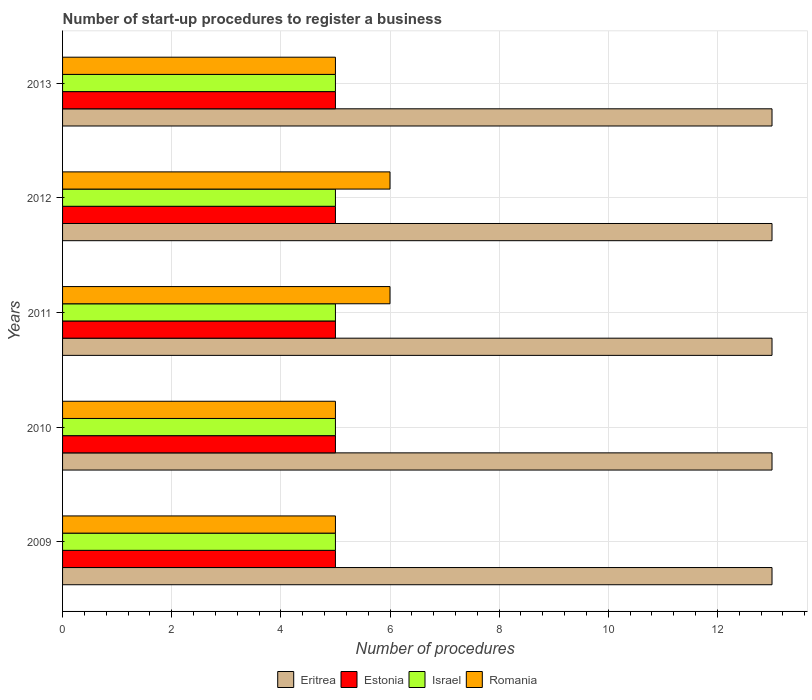How many different coloured bars are there?
Make the answer very short. 4. How many groups of bars are there?
Your answer should be compact. 5. Are the number of bars per tick equal to the number of legend labels?
Your answer should be very brief. Yes. Are the number of bars on each tick of the Y-axis equal?
Keep it short and to the point. Yes. How many bars are there on the 4th tick from the top?
Provide a succinct answer. 4. What is the label of the 3rd group of bars from the top?
Offer a terse response. 2011. In how many cases, is the number of bars for a given year not equal to the number of legend labels?
Give a very brief answer. 0. What is the number of procedures required to register a business in Israel in 2011?
Give a very brief answer. 5. Across all years, what is the maximum number of procedures required to register a business in Israel?
Ensure brevity in your answer.  5. In which year was the number of procedures required to register a business in Romania maximum?
Your response must be concise. 2011. What is the total number of procedures required to register a business in Israel in the graph?
Provide a succinct answer. 25. What is the difference between the number of procedures required to register a business in Israel in 2010 and that in 2012?
Offer a terse response. 0. In the year 2009, what is the difference between the number of procedures required to register a business in Israel and number of procedures required to register a business in Romania?
Your response must be concise. 0. What is the ratio of the number of procedures required to register a business in Estonia in 2012 to that in 2013?
Provide a succinct answer. 1. Is the number of procedures required to register a business in Eritrea in 2012 less than that in 2013?
Provide a succinct answer. No. Is the difference between the number of procedures required to register a business in Israel in 2012 and 2013 greater than the difference between the number of procedures required to register a business in Romania in 2012 and 2013?
Your answer should be compact. No. What is the difference between the highest and the lowest number of procedures required to register a business in Eritrea?
Give a very brief answer. 0. In how many years, is the number of procedures required to register a business in Estonia greater than the average number of procedures required to register a business in Estonia taken over all years?
Offer a terse response. 0. Is it the case that in every year, the sum of the number of procedures required to register a business in Eritrea and number of procedures required to register a business in Israel is greater than the sum of number of procedures required to register a business in Romania and number of procedures required to register a business in Estonia?
Your answer should be very brief. Yes. What does the 2nd bar from the top in 2012 represents?
Provide a succinct answer. Israel. What does the 1st bar from the bottom in 2010 represents?
Make the answer very short. Eritrea. Is it the case that in every year, the sum of the number of procedures required to register a business in Israel and number of procedures required to register a business in Estonia is greater than the number of procedures required to register a business in Romania?
Make the answer very short. Yes. How many bars are there?
Provide a succinct answer. 20. Are all the bars in the graph horizontal?
Offer a terse response. Yes. How many years are there in the graph?
Your response must be concise. 5. Does the graph contain any zero values?
Give a very brief answer. No. Does the graph contain grids?
Give a very brief answer. Yes. Where does the legend appear in the graph?
Offer a terse response. Bottom center. How are the legend labels stacked?
Ensure brevity in your answer.  Horizontal. What is the title of the graph?
Give a very brief answer. Number of start-up procedures to register a business. Does "Andorra" appear as one of the legend labels in the graph?
Make the answer very short. No. What is the label or title of the X-axis?
Provide a succinct answer. Number of procedures. What is the label or title of the Y-axis?
Your response must be concise. Years. What is the Number of procedures in Eritrea in 2009?
Provide a succinct answer. 13. What is the Number of procedures in Estonia in 2009?
Give a very brief answer. 5. What is the Number of procedures of Israel in 2009?
Give a very brief answer. 5. What is the Number of procedures in Romania in 2009?
Provide a succinct answer. 5. What is the Number of procedures of Eritrea in 2010?
Your response must be concise. 13. What is the Number of procedures in Estonia in 2010?
Your response must be concise. 5. What is the Number of procedures in Israel in 2010?
Keep it short and to the point. 5. What is the Number of procedures of Romania in 2010?
Keep it short and to the point. 5. What is the Number of procedures in Israel in 2011?
Provide a succinct answer. 5. What is the Number of procedures in Romania in 2011?
Make the answer very short. 6. What is the Number of procedures of Eritrea in 2012?
Your answer should be compact. 13. What is the Number of procedures in Estonia in 2012?
Your answer should be compact. 5. Across all years, what is the maximum Number of procedures in Eritrea?
Keep it short and to the point. 13. Across all years, what is the maximum Number of procedures of Romania?
Keep it short and to the point. 6. Across all years, what is the minimum Number of procedures of Eritrea?
Your answer should be very brief. 13. Across all years, what is the minimum Number of procedures of Israel?
Your answer should be compact. 5. Across all years, what is the minimum Number of procedures in Romania?
Your answer should be very brief. 5. What is the total Number of procedures in Eritrea in the graph?
Make the answer very short. 65. What is the total Number of procedures in Estonia in the graph?
Provide a succinct answer. 25. What is the difference between the Number of procedures in Estonia in 2009 and that in 2010?
Provide a succinct answer. 0. What is the difference between the Number of procedures of Romania in 2009 and that in 2010?
Your response must be concise. 0. What is the difference between the Number of procedures in Eritrea in 2009 and that in 2011?
Ensure brevity in your answer.  0. What is the difference between the Number of procedures of Romania in 2009 and that in 2012?
Give a very brief answer. -1. What is the difference between the Number of procedures of Eritrea in 2009 and that in 2013?
Provide a short and direct response. 0. What is the difference between the Number of procedures of Estonia in 2009 and that in 2013?
Provide a succinct answer. 0. What is the difference between the Number of procedures of Romania in 2009 and that in 2013?
Your answer should be compact. 0. What is the difference between the Number of procedures in Eritrea in 2010 and that in 2011?
Your response must be concise. 0. What is the difference between the Number of procedures of Estonia in 2010 and that in 2012?
Ensure brevity in your answer.  0. What is the difference between the Number of procedures in Israel in 2010 and that in 2012?
Provide a succinct answer. 0. What is the difference between the Number of procedures of Romania in 2010 and that in 2012?
Your answer should be very brief. -1. What is the difference between the Number of procedures of Estonia in 2010 and that in 2013?
Keep it short and to the point. 0. What is the difference between the Number of procedures of Israel in 2010 and that in 2013?
Provide a short and direct response. 0. What is the difference between the Number of procedures of Romania in 2010 and that in 2013?
Ensure brevity in your answer.  0. What is the difference between the Number of procedures of Eritrea in 2011 and that in 2012?
Offer a terse response. 0. What is the difference between the Number of procedures in Eritrea in 2011 and that in 2013?
Give a very brief answer. 0. What is the difference between the Number of procedures in Estonia in 2011 and that in 2013?
Ensure brevity in your answer.  0. What is the difference between the Number of procedures in Israel in 2011 and that in 2013?
Ensure brevity in your answer.  0. What is the difference between the Number of procedures of Estonia in 2012 and that in 2013?
Your answer should be compact. 0. What is the difference between the Number of procedures of Israel in 2012 and that in 2013?
Ensure brevity in your answer.  0. What is the difference between the Number of procedures of Romania in 2012 and that in 2013?
Your answer should be compact. 1. What is the difference between the Number of procedures of Eritrea in 2009 and the Number of procedures of Estonia in 2010?
Provide a short and direct response. 8. What is the difference between the Number of procedures of Eritrea in 2009 and the Number of procedures of Israel in 2010?
Your answer should be very brief. 8. What is the difference between the Number of procedures in Israel in 2009 and the Number of procedures in Romania in 2010?
Provide a succinct answer. 0. What is the difference between the Number of procedures in Estonia in 2009 and the Number of procedures in Israel in 2011?
Your answer should be very brief. 0. What is the difference between the Number of procedures of Israel in 2009 and the Number of procedures of Romania in 2011?
Your answer should be very brief. -1. What is the difference between the Number of procedures in Eritrea in 2009 and the Number of procedures in Estonia in 2012?
Make the answer very short. 8. What is the difference between the Number of procedures in Eritrea in 2009 and the Number of procedures in Israel in 2012?
Provide a succinct answer. 8. What is the difference between the Number of procedures of Eritrea in 2009 and the Number of procedures of Romania in 2012?
Provide a short and direct response. 7. What is the difference between the Number of procedures of Estonia in 2009 and the Number of procedures of Israel in 2012?
Your answer should be very brief. 0. What is the difference between the Number of procedures of Eritrea in 2009 and the Number of procedures of Israel in 2013?
Offer a very short reply. 8. What is the difference between the Number of procedures of Estonia in 2009 and the Number of procedures of Israel in 2013?
Make the answer very short. 0. What is the difference between the Number of procedures in Estonia in 2009 and the Number of procedures in Romania in 2013?
Offer a very short reply. 0. What is the difference between the Number of procedures of Israel in 2009 and the Number of procedures of Romania in 2013?
Your answer should be compact. 0. What is the difference between the Number of procedures of Eritrea in 2010 and the Number of procedures of Romania in 2011?
Ensure brevity in your answer.  7. What is the difference between the Number of procedures in Israel in 2010 and the Number of procedures in Romania in 2011?
Ensure brevity in your answer.  -1. What is the difference between the Number of procedures of Eritrea in 2010 and the Number of procedures of Israel in 2012?
Your response must be concise. 8. What is the difference between the Number of procedures of Eritrea in 2010 and the Number of procedures of Israel in 2013?
Offer a terse response. 8. What is the difference between the Number of procedures in Eritrea in 2010 and the Number of procedures in Romania in 2013?
Offer a very short reply. 8. What is the difference between the Number of procedures in Estonia in 2010 and the Number of procedures in Israel in 2013?
Give a very brief answer. 0. What is the difference between the Number of procedures in Eritrea in 2011 and the Number of procedures in Romania in 2012?
Provide a short and direct response. 7. What is the difference between the Number of procedures in Estonia in 2011 and the Number of procedures in Israel in 2012?
Make the answer very short. 0. What is the difference between the Number of procedures in Israel in 2011 and the Number of procedures in Romania in 2012?
Your response must be concise. -1. What is the difference between the Number of procedures in Eritrea in 2011 and the Number of procedures in Israel in 2013?
Your answer should be compact. 8. What is the difference between the Number of procedures in Eritrea in 2011 and the Number of procedures in Romania in 2013?
Keep it short and to the point. 8. What is the difference between the Number of procedures in Estonia in 2011 and the Number of procedures in Romania in 2013?
Your answer should be very brief. 0. What is the difference between the Number of procedures of Eritrea in 2012 and the Number of procedures of Romania in 2013?
Provide a succinct answer. 8. What is the difference between the Number of procedures in Estonia in 2012 and the Number of procedures in Israel in 2013?
Your answer should be compact. 0. What is the difference between the Number of procedures of Estonia in 2012 and the Number of procedures of Romania in 2013?
Make the answer very short. 0. What is the difference between the Number of procedures of Israel in 2012 and the Number of procedures of Romania in 2013?
Your answer should be very brief. 0. What is the average Number of procedures in Israel per year?
Ensure brevity in your answer.  5. In the year 2009, what is the difference between the Number of procedures in Eritrea and Number of procedures in Estonia?
Give a very brief answer. 8. In the year 2009, what is the difference between the Number of procedures in Israel and Number of procedures in Romania?
Make the answer very short. 0. In the year 2010, what is the difference between the Number of procedures in Eritrea and Number of procedures in Estonia?
Offer a very short reply. 8. In the year 2010, what is the difference between the Number of procedures of Estonia and Number of procedures of Israel?
Give a very brief answer. 0. In the year 2011, what is the difference between the Number of procedures in Eritrea and Number of procedures in Estonia?
Your answer should be compact. 8. In the year 2011, what is the difference between the Number of procedures in Eritrea and Number of procedures in Israel?
Keep it short and to the point. 8. In the year 2011, what is the difference between the Number of procedures in Estonia and Number of procedures in Israel?
Provide a short and direct response. 0. In the year 2011, what is the difference between the Number of procedures in Estonia and Number of procedures in Romania?
Your answer should be compact. -1. In the year 2011, what is the difference between the Number of procedures in Israel and Number of procedures in Romania?
Offer a terse response. -1. In the year 2012, what is the difference between the Number of procedures of Eritrea and Number of procedures of Estonia?
Ensure brevity in your answer.  8. In the year 2012, what is the difference between the Number of procedures of Israel and Number of procedures of Romania?
Offer a terse response. -1. In the year 2013, what is the difference between the Number of procedures in Eritrea and Number of procedures in Estonia?
Make the answer very short. 8. In the year 2013, what is the difference between the Number of procedures of Eritrea and Number of procedures of Israel?
Your answer should be very brief. 8. In the year 2013, what is the difference between the Number of procedures in Eritrea and Number of procedures in Romania?
Ensure brevity in your answer.  8. In the year 2013, what is the difference between the Number of procedures of Israel and Number of procedures of Romania?
Give a very brief answer. 0. What is the ratio of the Number of procedures in Estonia in 2009 to that in 2010?
Keep it short and to the point. 1. What is the ratio of the Number of procedures of Romania in 2009 to that in 2010?
Make the answer very short. 1. What is the ratio of the Number of procedures of Eritrea in 2009 to that in 2011?
Give a very brief answer. 1. What is the ratio of the Number of procedures of Eritrea in 2009 to that in 2012?
Your answer should be very brief. 1. What is the ratio of the Number of procedures of Estonia in 2009 to that in 2012?
Your answer should be very brief. 1. What is the ratio of the Number of procedures in Romania in 2009 to that in 2012?
Make the answer very short. 0.83. What is the ratio of the Number of procedures of Estonia in 2009 to that in 2013?
Your response must be concise. 1. What is the ratio of the Number of procedures of Israel in 2009 to that in 2013?
Provide a succinct answer. 1. What is the ratio of the Number of procedures in Romania in 2009 to that in 2013?
Give a very brief answer. 1. What is the ratio of the Number of procedures of Eritrea in 2010 to that in 2012?
Offer a terse response. 1. What is the ratio of the Number of procedures of Eritrea in 2010 to that in 2013?
Your answer should be compact. 1. What is the ratio of the Number of procedures in Estonia in 2010 to that in 2013?
Your answer should be compact. 1. What is the ratio of the Number of procedures of Romania in 2010 to that in 2013?
Ensure brevity in your answer.  1. What is the ratio of the Number of procedures of Eritrea in 2011 to that in 2012?
Keep it short and to the point. 1. What is the ratio of the Number of procedures in Estonia in 2011 to that in 2012?
Provide a succinct answer. 1. What is the ratio of the Number of procedures of Israel in 2011 to that in 2012?
Your response must be concise. 1. What is the ratio of the Number of procedures in Israel in 2011 to that in 2013?
Your answer should be compact. 1. What is the ratio of the Number of procedures in Romania in 2011 to that in 2013?
Offer a terse response. 1.2. What is the ratio of the Number of procedures of Eritrea in 2012 to that in 2013?
Provide a short and direct response. 1. What is the ratio of the Number of procedures of Israel in 2012 to that in 2013?
Ensure brevity in your answer.  1. What is the ratio of the Number of procedures of Romania in 2012 to that in 2013?
Make the answer very short. 1.2. What is the difference between the highest and the second highest Number of procedures in Israel?
Provide a short and direct response. 0. What is the difference between the highest and the lowest Number of procedures in Romania?
Ensure brevity in your answer.  1. 